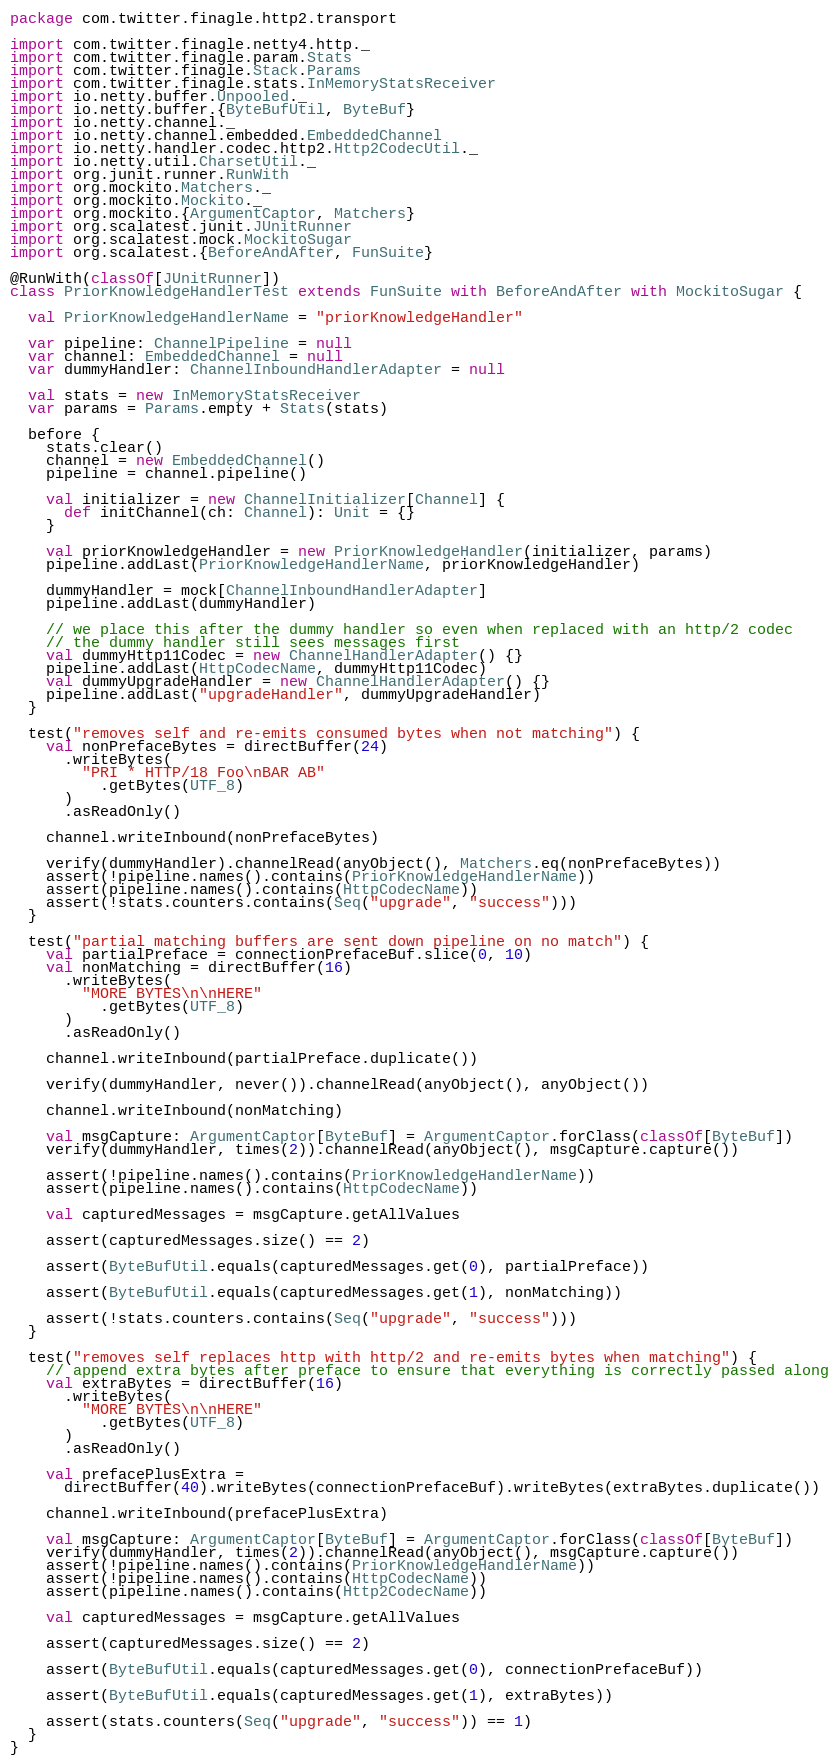<code> <loc_0><loc_0><loc_500><loc_500><_Scala_>package com.twitter.finagle.http2.transport

import com.twitter.finagle.netty4.http._
import com.twitter.finagle.param.Stats
import com.twitter.finagle.Stack.Params
import com.twitter.finagle.stats.InMemoryStatsReceiver
import io.netty.buffer.Unpooled._
import io.netty.buffer.{ByteBufUtil, ByteBuf}
import io.netty.channel._
import io.netty.channel.embedded.EmbeddedChannel
import io.netty.handler.codec.http2.Http2CodecUtil._
import io.netty.util.CharsetUtil._
import org.junit.runner.RunWith
import org.mockito.Matchers._
import org.mockito.Mockito._
import org.mockito.{ArgumentCaptor, Matchers}
import org.scalatest.junit.JUnitRunner
import org.scalatest.mock.MockitoSugar
import org.scalatest.{BeforeAndAfter, FunSuite}

@RunWith(classOf[JUnitRunner])
class PriorKnowledgeHandlerTest extends FunSuite with BeforeAndAfter with MockitoSugar {

  val PriorKnowledgeHandlerName = "priorKnowledgeHandler"

  var pipeline: ChannelPipeline = null
  var channel: EmbeddedChannel = null
  var dummyHandler: ChannelInboundHandlerAdapter = null

  val stats = new InMemoryStatsReceiver
  var params = Params.empty + Stats(stats)

  before {
    stats.clear()
    channel = new EmbeddedChannel()
    pipeline = channel.pipeline()

    val initializer = new ChannelInitializer[Channel] {
      def initChannel(ch: Channel): Unit = {}
    }

    val priorKnowledgeHandler = new PriorKnowledgeHandler(initializer, params)
    pipeline.addLast(PriorKnowledgeHandlerName, priorKnowledgeHandler)

    dummyHandler = mock[ChannelInboundHandlerAdapter]
    pipeline.addLast(dummyHandler)

    // we place this after the dummy handler so even when replaced with an http/2 codec
    // the dummy handler still sees messages first
    val dummyHttp11Codec = new ChannelHandlerAdapter() {}
    pipeline.addLast(HttpCodecName, dummyHttp11Codec)
    val dummyUpgradeHandler = new ChannelHandlerAdapter() {}
    pipeline.addLast("upgradeHandler", dummyUpgradeHandler)
  }

  test("removes self and re-emits consumed bytes when not matching") {
    val nonPrefaceBytes = directBuffer(24)
      .writeBytes(
        "PRI * HTTP/18 Foo\nBAR AB"
          .getBytes(UTF_8)
      )
      .asReadOnly()

    channel.writeInbound(nonPrefaceBytes)

    verify(dummyHandler).channelRead(anyObject(), Matchers.eq(nonPrefaceBytes))
    assert(!pipeline.names().contains(PriorKnowledgeHandlerName))
    assert(pipeline.names().contains(HttpCodecName))
    assert(!stats.counters.contains(Seq("upgrade", "success")))
  }

  test("partial matching buffers are sent down pipeline on no match") {
    val partialPreface = connectionPrefaceBuf.slice(0, 10)
    val nonMatching = directBuffer(16)
      .writeBytes(
        "MORE BYTES\n\nHERE"
          .getBytes(UTF_8)
      )
      .asReadOnly()

    channel.writeInbound(partialPreface.duplicate())

    verify(dummyHandler, never()).channelRead(anyObject(), anyObject())

    channel.writeInbound(nonMatching)

    val msgCapture: ArgumentCaptor[ByteBuf] = ArgumentCaptor.forClass(classOf[ByteBuf])
    verify(dummyHandler, times(2)).channelRead(anyObject(), msgCapture.capture())

    assert(!pipeline.names().contains(PriorKnowledgeHandlerName))
    assert(pipeline.names().contains(HttpCodecName))

    val capturedMessages = msgCapture.getAllValues

    assert(capturedMessages.size() == 2)

    assert(ByteBufUtil.equals(capturedMessages.get(0), partialPreface))

    assert(ByteBufUtil.equals(capturedMessages.get(1), nonMatching))

    assert(!stats.counters.contains(Seq("upgrade", "success")))
  }

  test("removes self replaces http with http/2 and re-emits bytes when matching") {
    // append extra bytes after preface to ensure that everything is correctly passed along
    val extraBytes = directBuffer(16)
      .writeBytes(
        "MORE BYTES\n\nHERE"
          .getBytes(UTF_8)
      )
      .asReadOnly()

    val prefacePlusExtra =
      directBuffer(40).writeBytes(connectionPrefaceBuf).writeBytes(extraBytes.duplicate())

    channel.writeInbound(prefacePlusExtra)

    val msgCapture: ArgumentCaptor[ByteBuf] = ArgumentCaptor.forClass(classOf[ByteBuf])
    verify(dummyHandler, times(2)).channelRead(anyObject(), msgCapture.capture())
    assert(!pipeline.names().contains(PriorKnowledgeHandlerName))
    assert(!pipeline.names().contains(HttpCodecName))
    assert(pipeline.names().contains(Http2CodecName))

    val capturedMessages = msgCapture.getAllValues

    assert(capturedMessages.size() == 2)

    assert(ByteBufUtil.equals(capturedMessages.get(0), connectionPrefaceBuf))

    assert(ByteBufUtil.equals(capturedMessages.get(1), extraBytes))

    assert(stats.counters(Seq("upgrade", "success")) == 1)
  }
}
</code> 